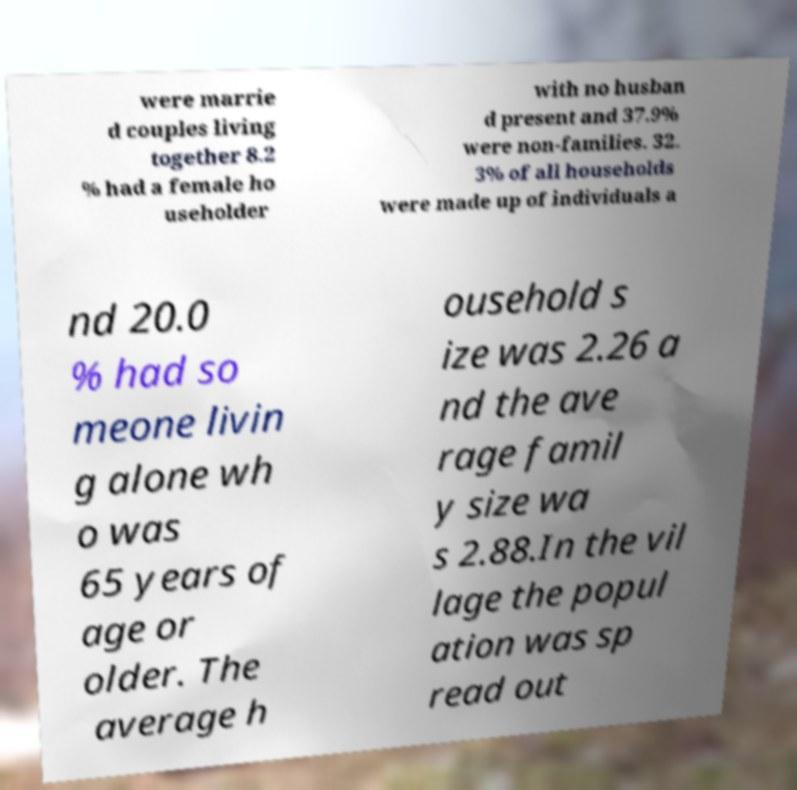For documentation purposes, I need the text within this image transcribed. Could you provide that? were marrie d couples living together 8.2 % had a female ho useholder with no husban d present and 37.9% were non-families. 32. 3% of all households were made up of individuals a nd 20.0 % had so meone livin g alone wh o was 65 years of age or older. The average h ousehold s ize was 2.26 a nd the ave rage famil y size wa s 2.88.In the vil lage the popul ation was sp read out 